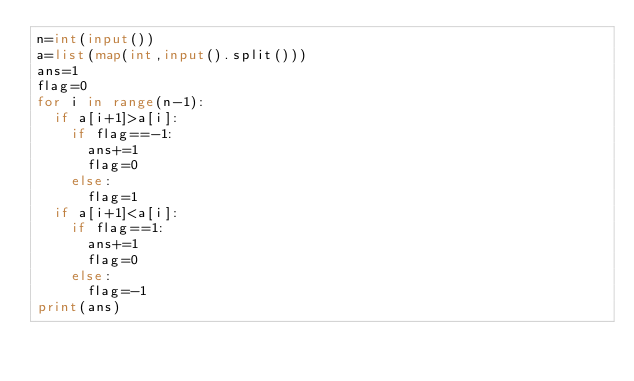Convert code to text. <code><loc_0><loc_0><loc_500><loc_500><_Python_>n=int(input())
a=list(map(int,input().split()))
ans=1
flag=0
for i in range(n-1):
  if a[i+1]>a[i]:
    if flag==-1:
      ans+=1
      flag=0
    else:
      flag=1
  if a[i+1]<a[i]:
    if flag==1:
      ans+=1
      flag=0
    else:
      flag=-1
print(ans)
</code> 